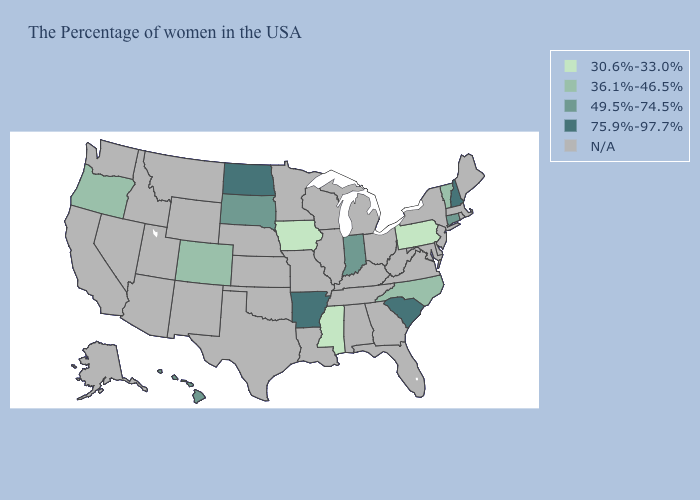What is the value of Wyoming?
Answer briefly. N/A. Name the states that have a value in the range N/A?
Quick response, please. Maine, Massachusetts, Rhode Island, New York, New Jersey, Delaware, Maryland, Virginia, West Virginia, Ohio, Florida, Georgia, Michigan, Kentucky, Alabama, Tennessee, Wisconsin, Illinois, Louisiana, Missouri, Minnesota, Kansas, Nebraska, Oklahoma, Texas, Wyoming, New Mexico, Utah, Montana, Arizona, Idaho, Nevada, California, Washington, Alaska. What is the value of Massachusetts?
Write a very short answer. N/A. What is the value of Tennessee?
Concise answer only. N/A. Among the states that border Georgia , does North Carolina have the highest value?
Concise answer only. No. Which states hav the highest value in the West?
Keep it brief. Hawaii. Does Pennsylvania have the lowest value in the Northeast?
Keep it brief. Yes. Does Pennsylvania have the highest value in the Northeast?
Quick response, please. No. What is the value of Minnesota?
Quick response, please. N/A. What is the value of Indiana?
Answer briefly. 49.5%-74.5%. What is the value of New York?
Write a very short answer. N/A. Is the legend a continuous bar?
Quick response, please. No. 